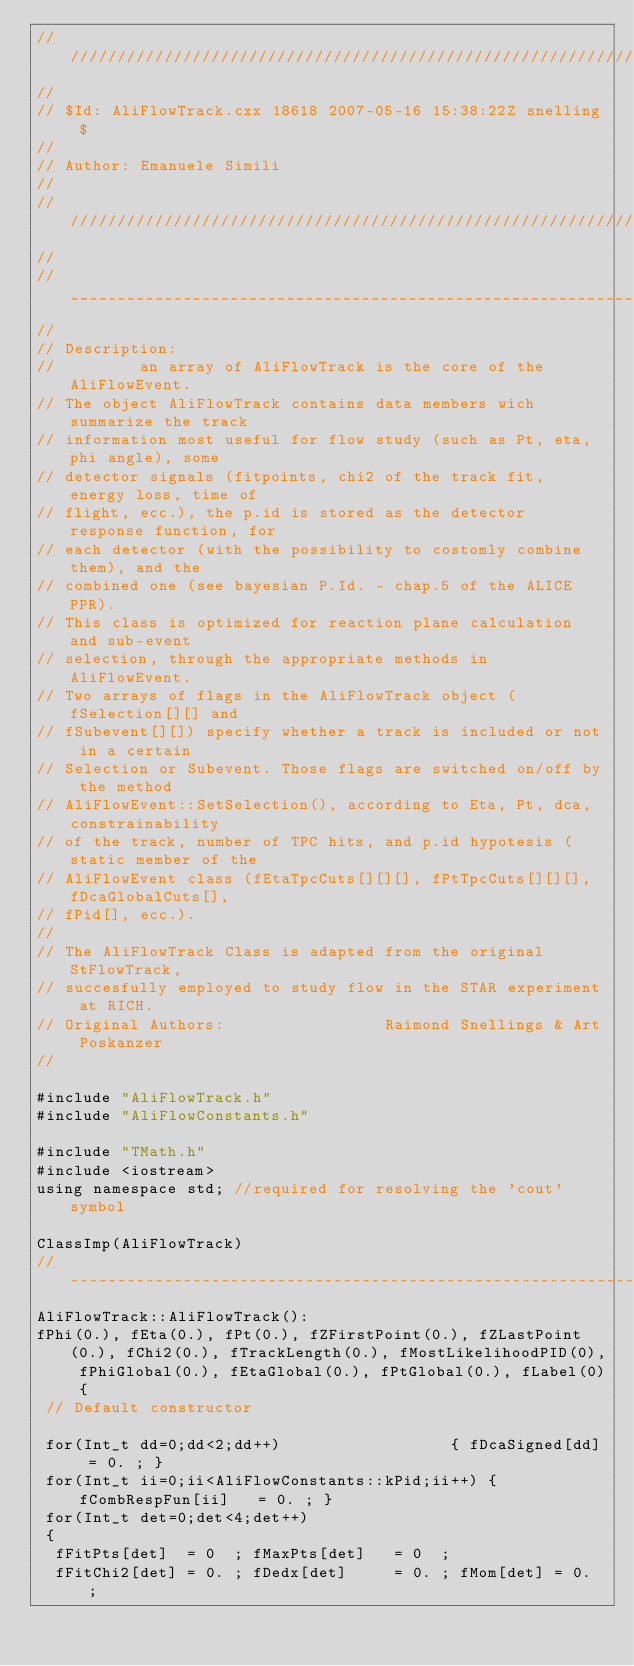<code> <loc_0><loc_0><loc_500><loc_500><_C++_>//////////////////////////////////////////////////////////////////////
//
// $Id: AliFlowTrack.cxx 18618 2007-05-16 15:38:22Z snelling $
//
// Author: Emanuele Simili
//
//////////////////////////////////////////////////////////////////////
//
//_____________________________________________________________
//
// Description: 
//         an array of AliFlowTrack is the core of the AliFlowEvent. 
// The object AliFlowTrack contains data members wich summarize the track 
// information most useful for flow study (such as Pt, eta, phi angle), some 
// detector signals (fitpoints, chi2 of the track fit, energy loss, time of 
// flight, ecc.), the p.id is stored as the detector response function, for 
// each detector (with the possibility to costomly combine them), and the 
// combined one (see bayesian P.Id. - chap.5 of the ALICE PPR). 
// This class is optimized for reaction plane calculation and sub-event 
// selection, through the appropriate methods in AliFlowEvent.  
// Two arrays of flags in the AliFlowTrack object (fSelection[][] and 
// fSubevent[][]) specify whether a track is included or not in a certain 
// Selection or Subevent. Those flags are switched on/off by the method 
// AliFlowEvent::SetSelection(), according to Eta, Pt, dca, constrainability  
// of the track, number of TPC hits, and p.id hypotesis (static member of the
// AliFlowEvent class (fEtaTpcCuts[][][], fPtTpcCuts[][][], fDcaGlobalCuts[], 
// fPid[], ecc.). 
//
// The AliFlowTrack Class is adapted from the original StFlowTrack,
// succesfully employed to study flow in the STAR experiment at RICH.
// Original Authors:                 Raimond Snellings & Art Poskanzer
//

#include "AliFlowTrack.h"
#include "AliFlowConstants.h"

#include "TMath.h"
#include <iostream>
using namespace std; //required for resolving the 'cout' symbol

ClassImp(AliFlowTrack)
//-------------------------------------------------------------
AliFlowTrack::AliFlowTrack():
fPhi(0.), fEta(0.), fPt(0.), fZFirstPoint(0.), fZLastPoint(0.), fChi2(0.), fTrackLength(0.), fMostLikelihoodPID(0), fPhiGlobal(0.), fEtaGlobal(0.), fPtGlobal(0.), fLabel(0) {
 // Default constructor
 
 for(Int_t dd=0;dd<2;dd++) 	                { fDcaSigned[dd] = 0. ; }			      
 for(Int_t ii=0;ii<AliFlowConstants::kPid;ii++) { fCombRespFun[ii]   = 0. ; }
 for(Int_t det=0;det<4;det++)
 {
  fFitPts[det]  = 0  ; fMaxPts[det]   = 0  ; 
  fFitChi2[det] = 0. ; fDedx[det]     = 0. ; fMom[det] = 0. ; </code> 